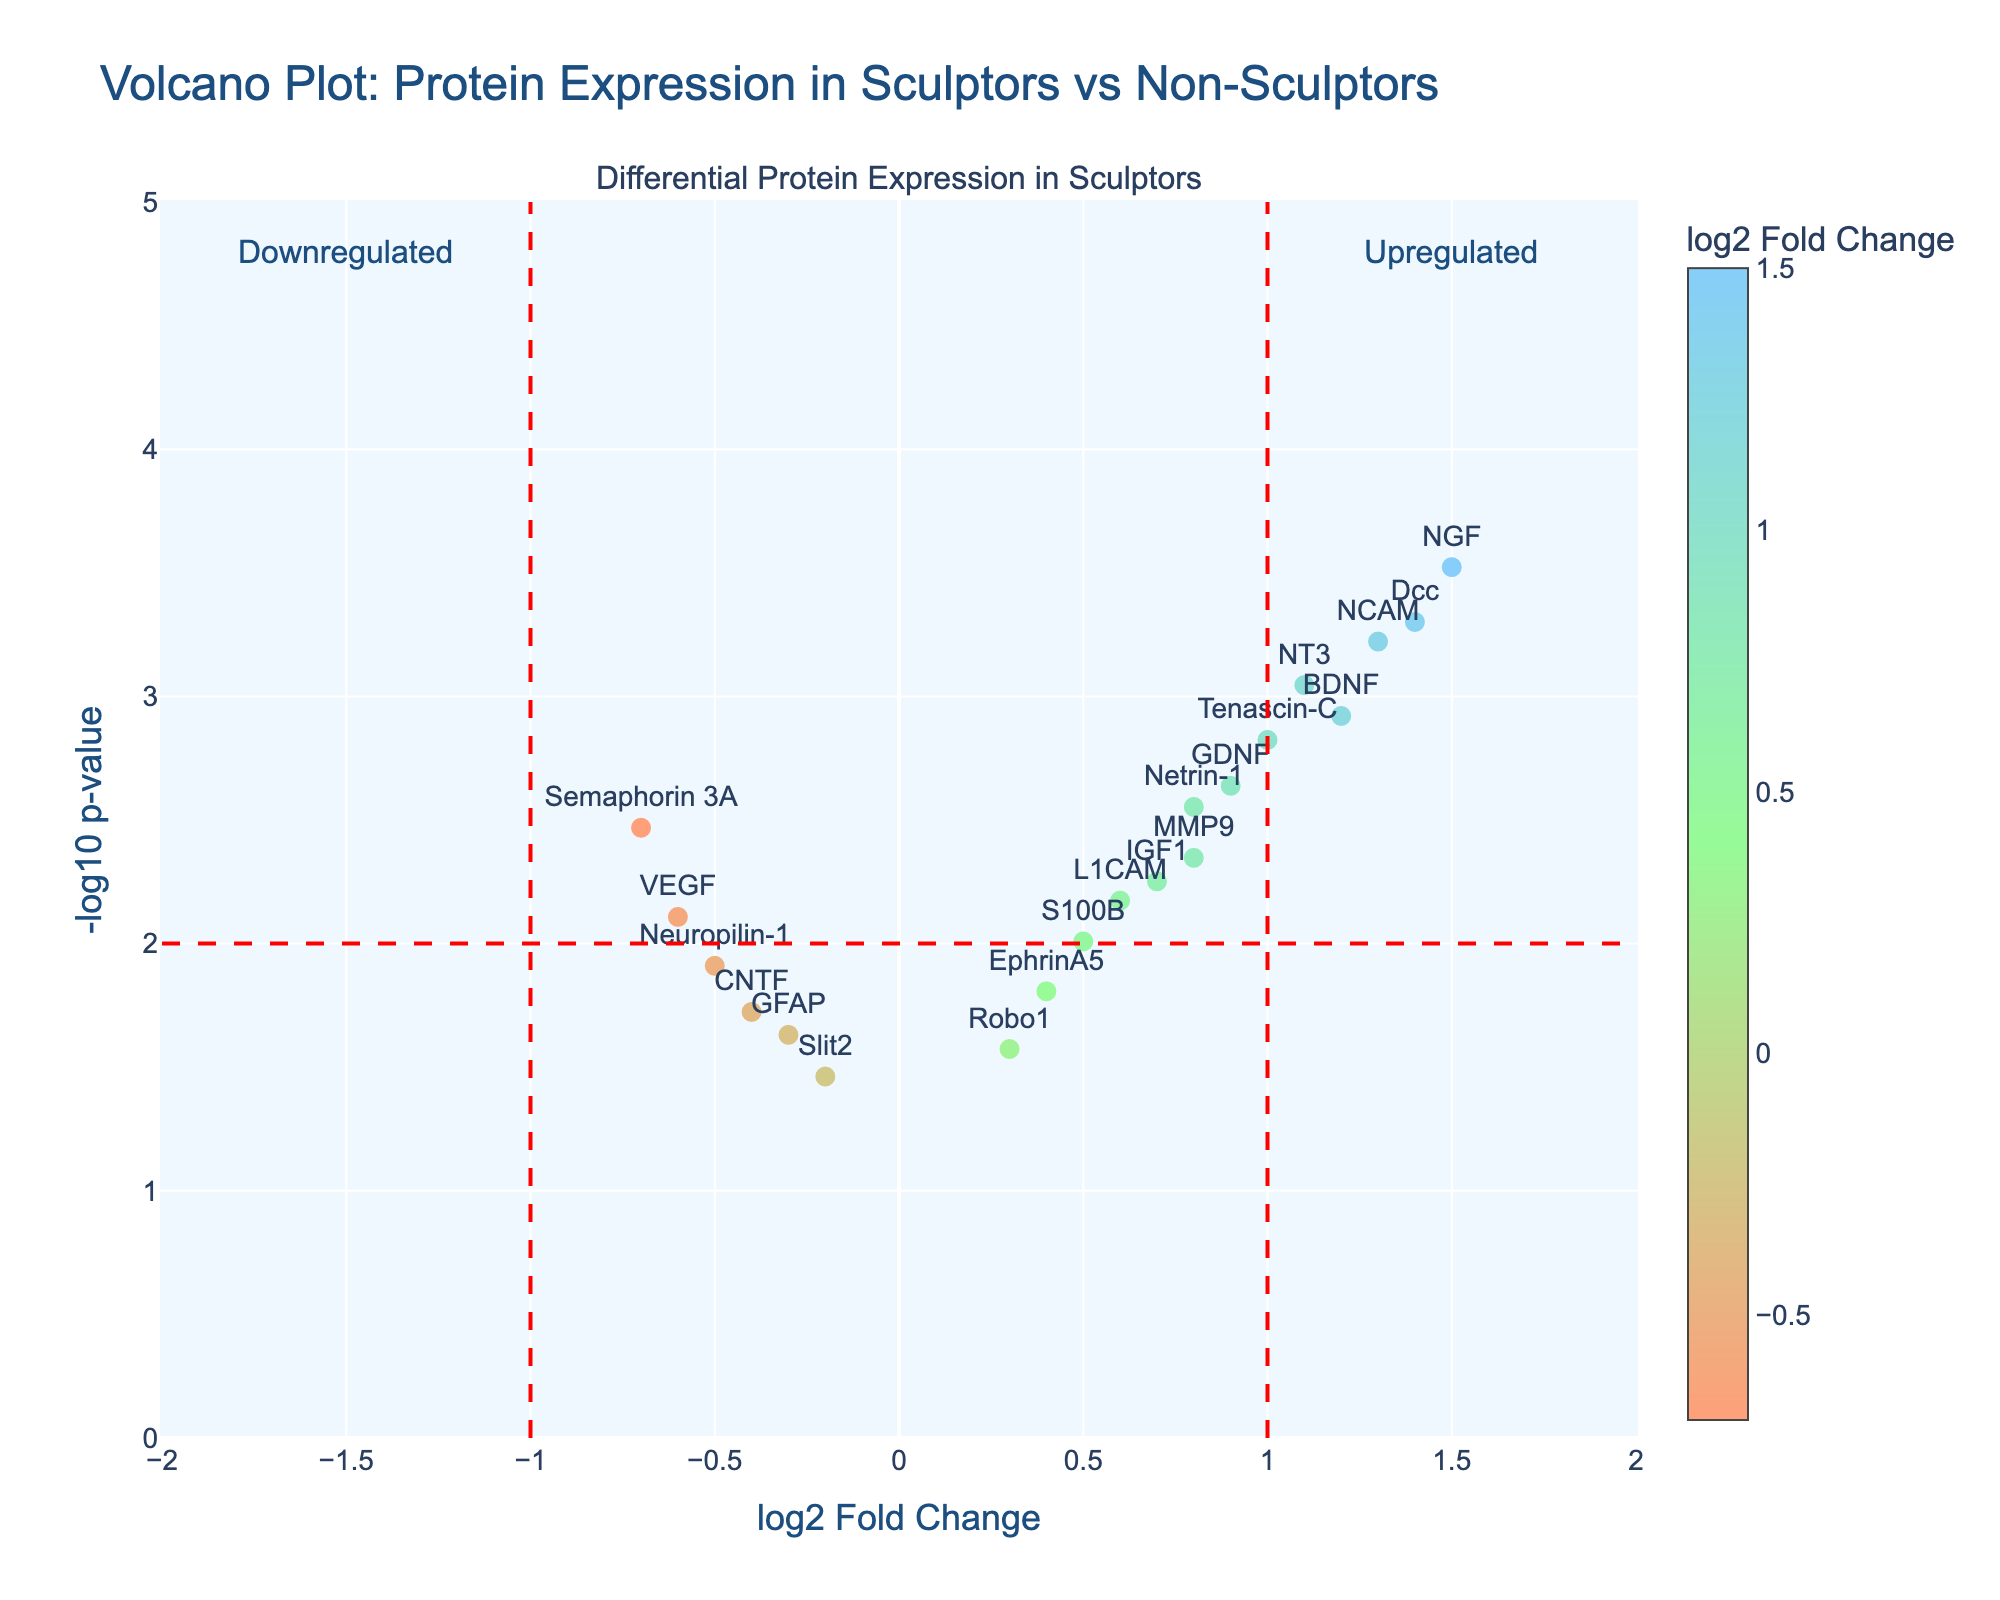What's the title of the plot? The title of the plot is found at the top of the figure and provides a summary of what the plot represents. In this case, it's related to protein expression in sculptors compared to non-sculptors.
Answer: Volcano Plot: Protein Expression in Sculptors vs Non-Sculptors What do the x-axis and y-axis represent? The x-axis shows the log2 fold change of protein expression, which indicates the relative change in expression levels between sculptors and non-sculptors. The y-axis shows the -log10 p-value, representing the statistical significance of the changes.
Answer: x-axis: log2 Fold Change, y-axis: -log10 p-value How many proteins show a significant upregulation in sculptors compared to non-sculptors? Significant upregulation can be identified by points on the right of the x=1 red threshold line and above the y=2 threshold line. By identifying proteins in this region, we can determine the count.
Answer: 6 Which protein has the highest log2 fold change? By observing the x-axis, the protein with the highest value is the protein farthest to the right. This can be confirmed by referencing the hover text annotations.
Answer: NGF What's the range of -log10 p-values observed in the plot? By examining the y-axis range of the scatter points and taking note of the uppermost and lowermost points on the plot, we can determine the range of -log10 p-values.
Answer: 0.3 to 3.5 How many data points are there in the figure? By counting all individual points in the scatter plot, each representing a protein, we can determine the total number of data points.
Answer: 18 Are there more upregulated or downregulated proteins? By counting the number of points to the right of the x=1 line (upregulated) and to the left of the x=-1 line (downregulated), we can compare the quantities.
Answer: More upregulated Which protein associated with guidance of neuron growth is significantly downregulated? Guidance of neuron growth could involve specific proteins, identified by their positions in the plot. We focus on those on the left of the x=-1 line and above y=2.
Answer: Semaphorin 3A What defines the color of the data points in the plot? The color of the data points changes based on their log2 fold change values. Colors range from warm to cool colors as indicated by the color scale to the right of the plot.
Answer: log2 fold change 